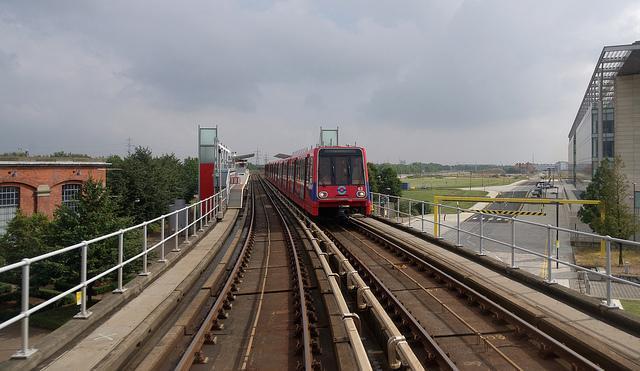How many tracks?
Give a very brief answer. 2. 